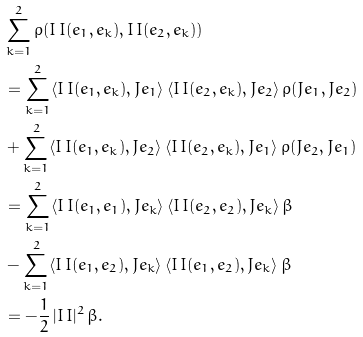<formula> <loc_0><loc_0><loc_500><loc_500>& \sum _ { k = 1 } ^ { 2 } \rho ( I \, I ( e _ { 1 } , e _ { k } ) , I \, I ( e _ { 2 } , e _ { k } ) ) \\ & = \sum _ { k = 1 } ^ { 2 } \langle I \, I ( e _ { 1 } , e _ { k } ) , J e _ { 1 } \rangle \, \langle I \, I ( e _ { 2 } , e _ { k } ) , J e _ { 2 } \rangle \, \rho ( J e _ { 1 } , J e _ { 2 } ) \\ & + \sum _ { k = 1 } ^ { 2 } \langle I \, I ( e _ { 1 } , e _ { k } ) , J e _ { 2 } \rangle \, \langle I \, I ( e _ { 2 } , e _ { k } ) , J e _ { 1 } \rangle \, \rho ( J e _ { 2 } , J e _ { 1 } ) \\ & = \sum _ { k = 1 } ^ { 2 } \langle I \, I ( e _ { 1 } , e _ { 1 } ) , J e _ { k } \rangle \, \langle I \, I ( e _ { 2 } , e _ { 2 } ) , J e _ { k } \rangle \, \beta \\ & - \sum _ { k = 1 } ^ { 2 } \langle I \, I ( e _ { 1 } , e _ { 2 } ) , J e _ { k } \rangle \, \langle I \, I ( e _ { 1 } , e _ { 2 } ) , J e _ { k } \rangle \, \beta \\ & = - \frac { 1 } { 2 } \, | I \, I | ^ { 2 } \, \beta .</formula> 